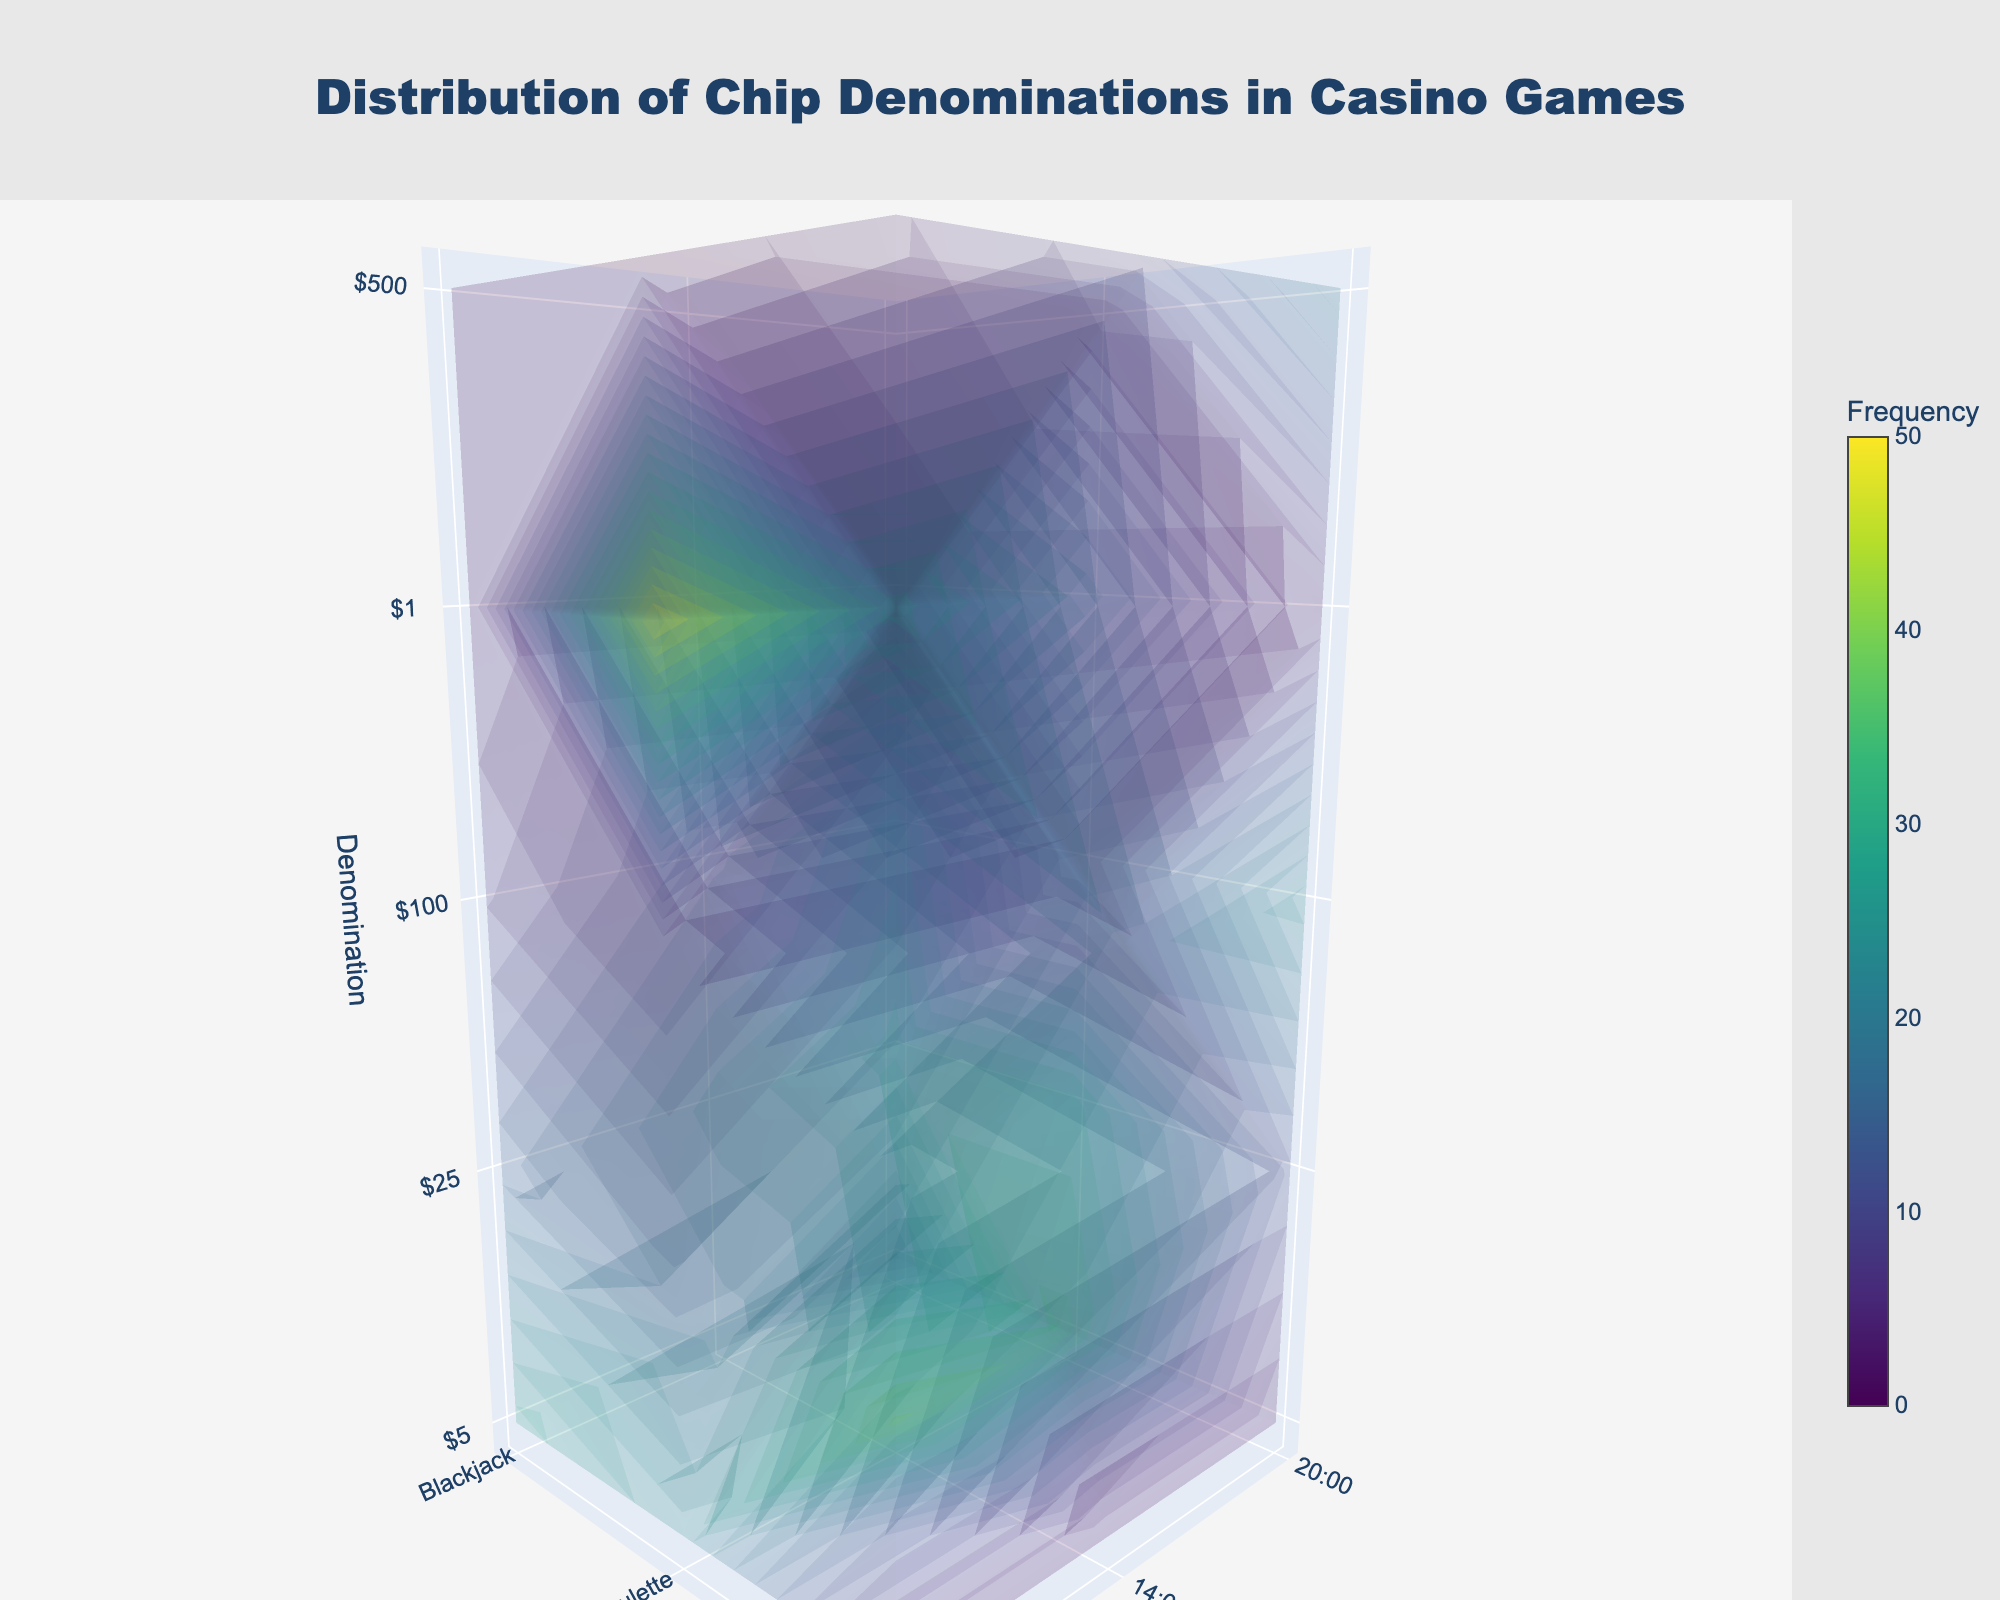What are the main elements in the title? The title emphasizes the distribution of chip denominations in casino games. It uses a larger font size, with a specific color and font family, and is centrally aligned at the top of the figure. Lastly, it provides context about the content and purpose of the plot.
Answer: Distribution of Chip Denominations in Casino Games How many time slots are displayed and what are they? The figure displays three time slots, which are represented on the y-axis. By looking at the tick values and labels on this axis, we can identify them.
Answer: 9:00, 14:00, 20:00 Which game has the highest frequency of $100 chips at 14:00? To determine this, we need to look at the intersection of the x-axis (games), y-axis (time 14:00), and z-axis ($100 denomination) and identify the game with the highest value for the frequency volume.
Answer: Poker During which time slot is the $5 denomination chip frequency highest in Roulette? We need to inspect the y-axis (time slots) and z-axis ($5 denomination) intersection values for Roulette and compare the frequencies. The highest value will indicate the time slot.
Answer: 14:00 Among all games, which denomination is used the most frequently at 9:00? We need to compare the frequencies of all denominations (z-axis values) at 9:00 for all games and identify the highest frequency number to find the corresponding denomination.
Answer: $1 in Roulette Which game has the lowest overall frequency of $5 chips throughout the day? This requires aggregating the frequencies of $5 chips for each game across all time slots and identifying the game with the lowest total frequency.
Answer: Blackjack Compare the use of $25 chips at 20:00 between Blackjack and Poker. Which game uses them more frequently? To answer this, we need to compare the frequency values of $25 chips (z-axis) for both Blackjack and Poker at the 20:00 time slot identified on the y-axis.
Answer: Blackjack What is the total frequency of $500 chips in Poker throughout the day? We need to sum up the frequency values of $500 chips (z-axis) for Poker across all time slots (y-axis) to get the total value.
Answer: 35 What's the trend of $1 chip usage in Roulette over the day? By examining the z-axis values for $1 chips in Roulette across the three y-axis time slots, we can observe whether the frequency increases, decreases, or remains stable.
Answer: Decreasing trend How does the overall frequency of chip usage change from 9:00 to 20:00 in Roulette? We need to sum up the frequencies of all denominations for Roulette at 9:00 and 20:00 to compare the total chip usage between these two time slots.
Answer: Decreases 